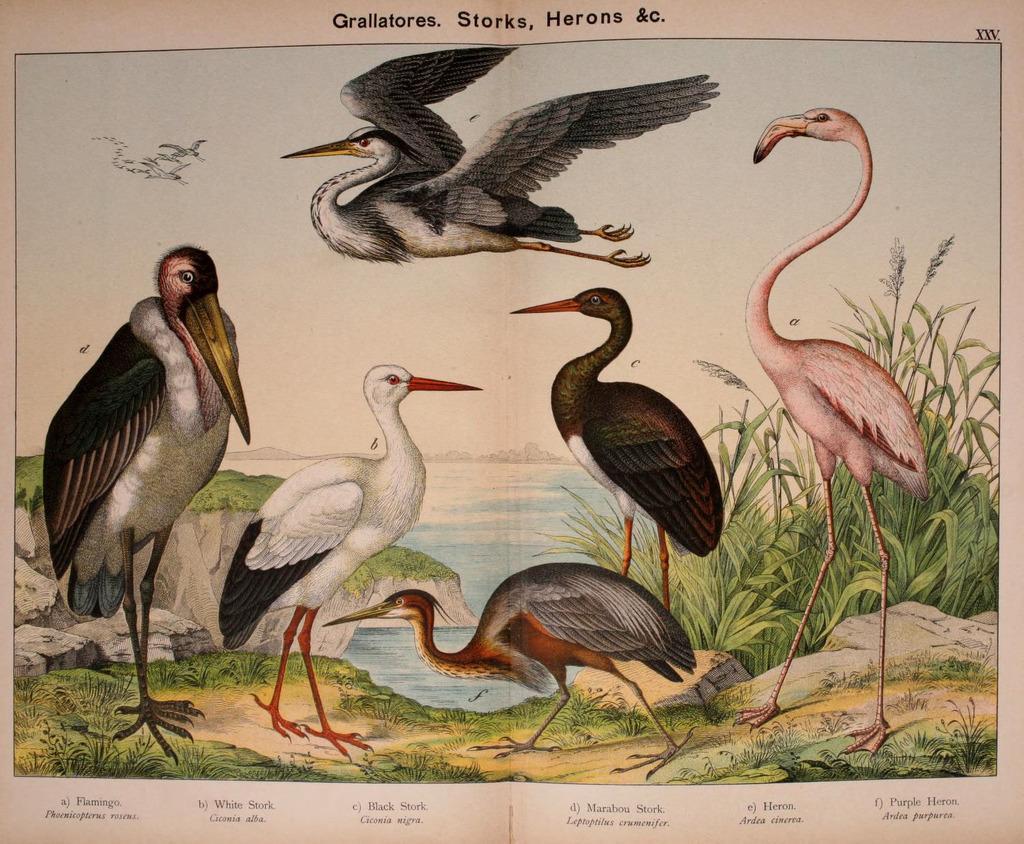Could you give a brief overview of what you see in this image? In this image we can see birds on the paper. At the bottom of the image there is text. 